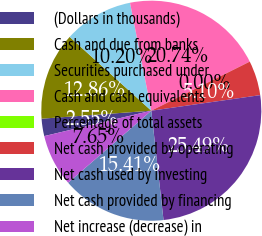Convert chart. <chart><loc_0><loc_0><loc_500><loc_500><pie_chart><fcel>(Dollars in thousands)<fcel>Cash and due from banks<fcel>Securities purchased under<fcel>Cash and cash equivalents<fcel>Percentage of total assets<fcel>Net cash provided by operating<fcel>Net cash used by investing<fcel>Net cash provided by financing<fcel>Net increase (decrease) in<nl><fcel>2.55%<fcel>12.86%<fcel>10.2%<fcel>20.74%<fcel>0.0%<fcel>5.1%<fcel>25.49%<fcel>15.41%<fcel>7.65%<nl></chart> 